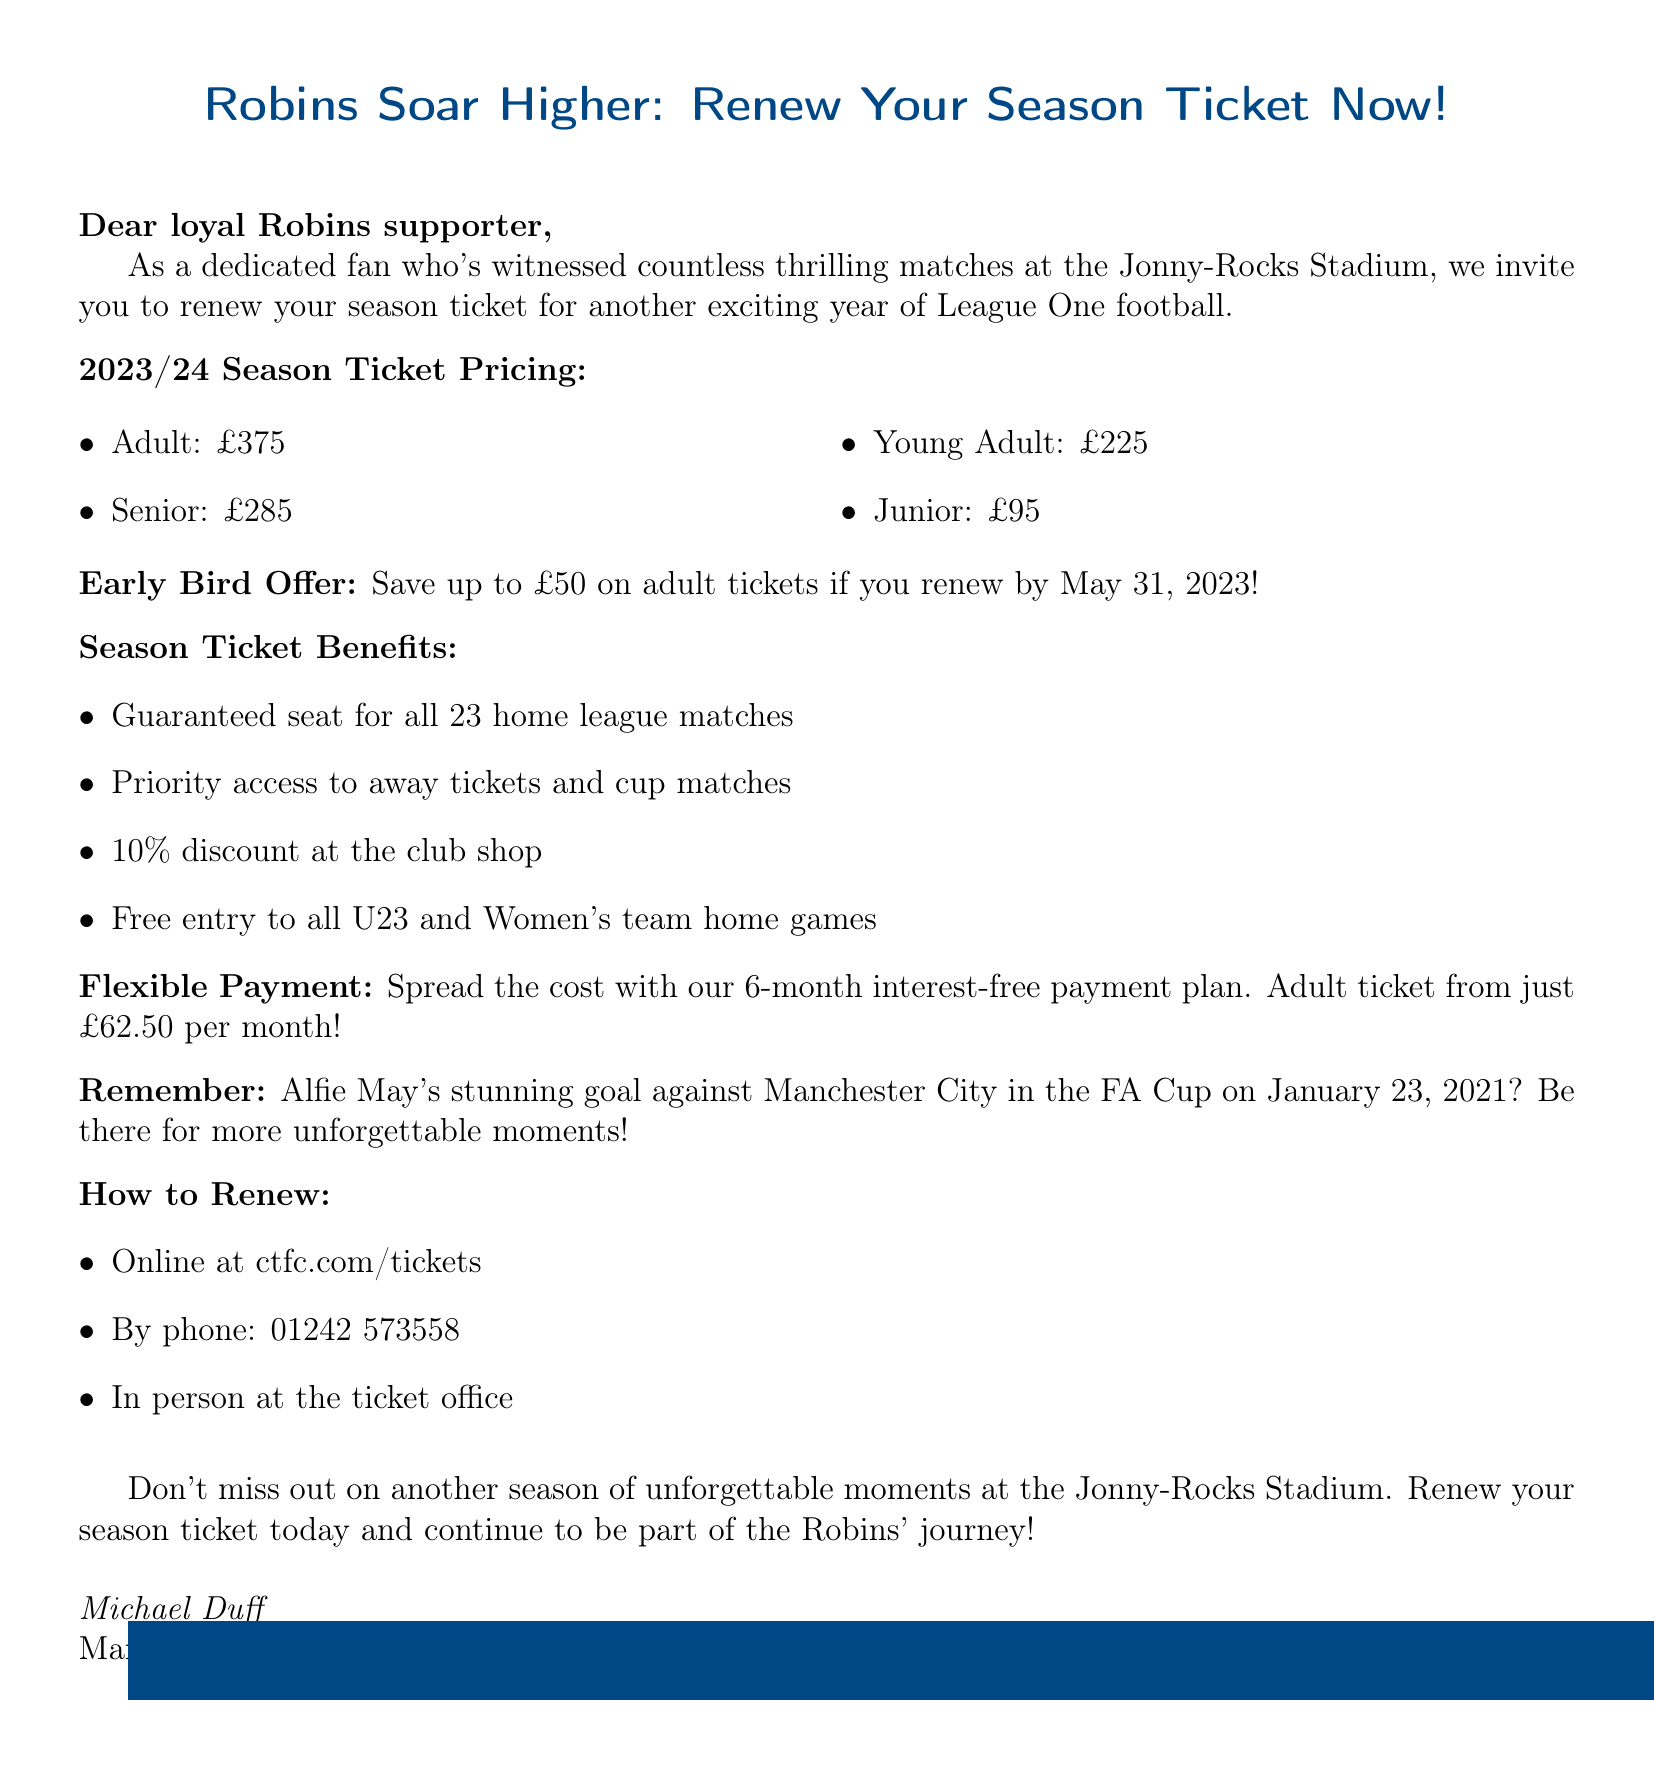What is the adult season ticket price? The document specifies the pricing options and lists the adult season ticket price as £375.
Answer: £375 What is the early bird discount deadline? The document mentions the early bird discount applicable until a specific date, which is May 31, 2023.
Answer: May 31, 2023 What are the benefits of having a season ticket? The document lists several benefits for season ticket holders, including guaranteed seating for matches and discounts at the club shop.
Answer: Guaranteed seat for all 23 home league matches How much can an adult save with the early bird discount? The document states that an adult can save up to £50 if they renew their season ticket before the deadline.
Answer: £50 What is the monthly payment plan for adults? The document describes the payment plan available, specifically stating how much an adult ticket costs per month.
Answer: £62.50 per month What memorable event is mentioned in the document? The document references a specific memorable moment related to a goal scored by a player on a particular date.
Answer: Alfie May's stunning goal against Manchester City in the FA Cup How can fans renew their season tickets? The document details the various methods for renewing season tickets, which includes online, by phone, and in person.
Answer: Online at ctfc.com/tickets What is the slogan for this season ticket renewal? The document presents a slogan that encourages fans to renew their season ticket, which is prominently displayed.
Answer: Robins Soar Higher: Renew Your Season Ticket Now! 